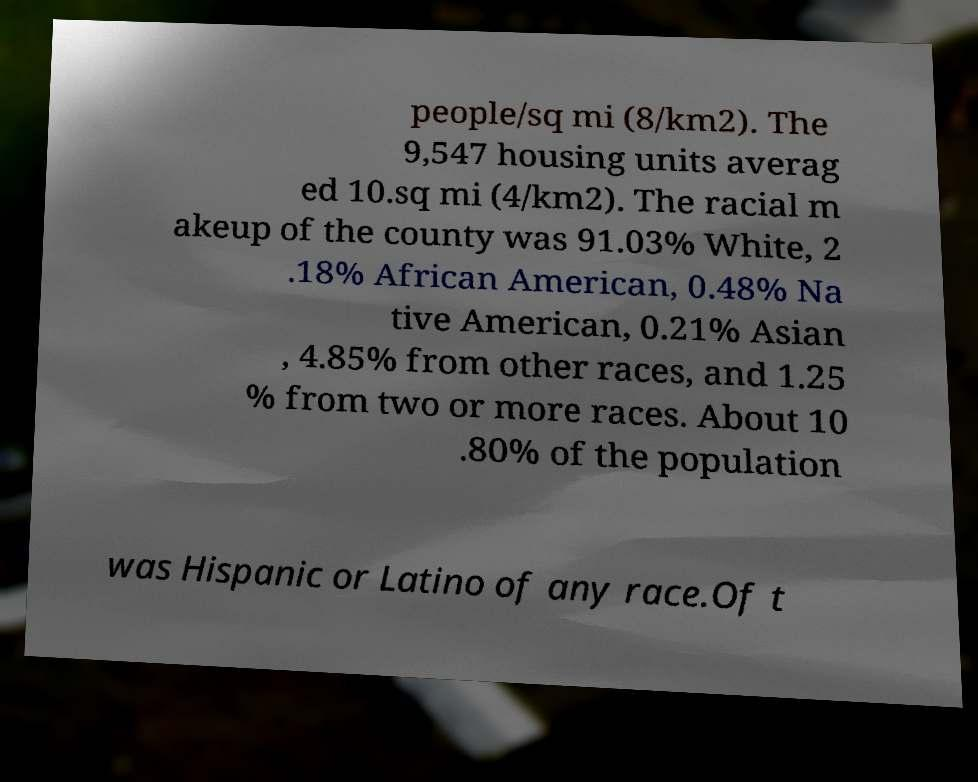Can you accurately transcribe the text from the provided image for me? people/sq mi (8/km2). The 9,547 housing units averag ed 10.sq mi (4/km2). The racial m akeup of the county was 91.03% White, 2 .18% African American, 0.48% Na tive American, 0.21% Asian , 4.85% from other races, and 1.25 % from two or more races. About 10 .80% of the population was Hispanic or Latino of any race.Of t 